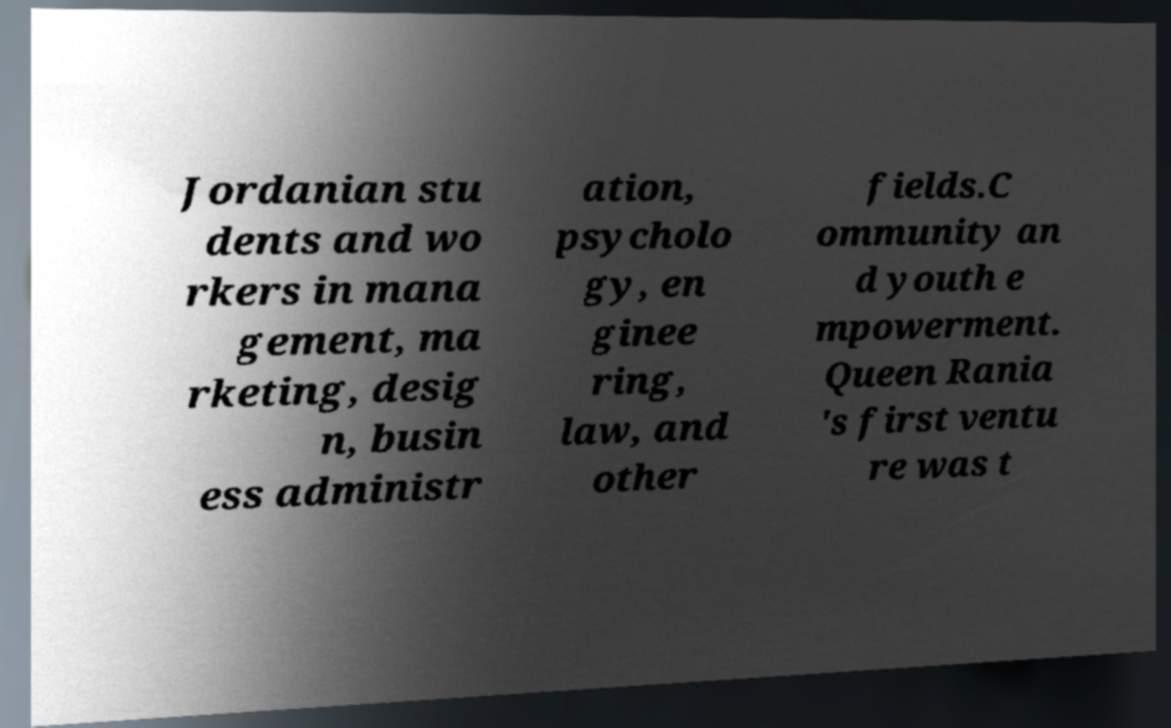What messages or text are displayed in this image? I need them in a readable, typed format. Jordanian stu dents and wo rkers in mana gement, ma rketing, desig n, busin ess administr ation, psycholo gy, en ginee ring, law, and other fields.C ommunity an d youth e mpowerment. Queen Rania 's first ventu re was t 